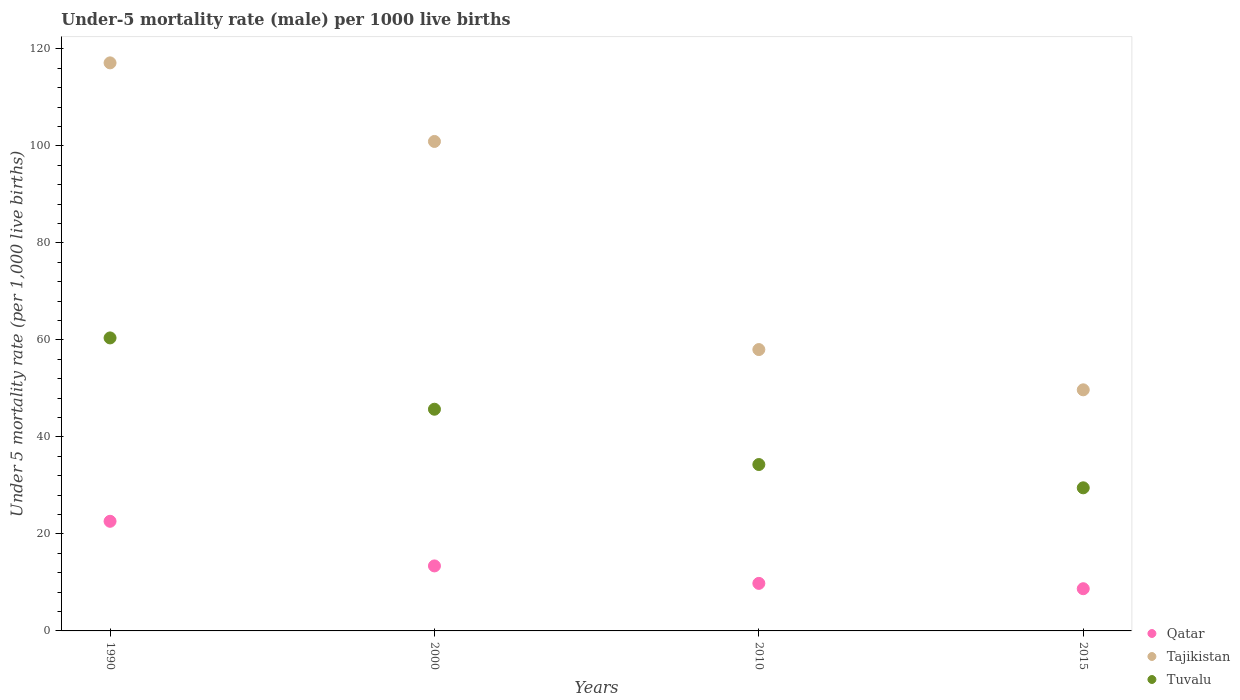What is the under-five mortality rate in Tuvalu in 2015?
Your response must be concise. 29.5. Across all years, what is the maximum under-five mortality rate in Qatar?
Your answer should be very brief. 22.6. In which year was the under-five mortality rate in Tajikistan minimum?
Your answer should be compact. 2015. What is the total under-five mortality rate in Tuvalu in the graph?
Your answer should be very brief. 169.9. What is the difference between the under-five mortality rate in Tajikistan in 1990 and that in 2015?
Your answer should be very brief. 67.4. What is the difference between the under-five mortality rate in Tajikistan in 2000 and the under-five mortality rate in Qatar in 2010?
Provide a short and direct response. 91.1. What is the average under-five mortality rate in Qatar per year?
Provide a succinct answer. 13.62. In the year 2000, what is the difference between the under-five mortality rate in Tajikistan and under-five mortality rate in Tuvalu?
Your response must be concise. 55.2. What is the ratio of the under-five mortality rate in Qatar in 2000 to that in 2015?
Offer a very short reply. 1.54. Is the under-five mortality rate in Tajikistan in 2010 less than that in 2015?
Give a very brief answer. No. Is the difference between the under-five mortality rate in Tajikistan in 1990 and 2000 greater than the difference between the under-five mortality rate in Tuvalu in 1990 and 2000?
Your answer should be very brief. Yes. What is the difference between the highest and the second highest under-five mortality rate in Tuvalu?
Provide a succinct answer. 14.7. What is the difference between the highest and the lowest under-five mortality rate in Tuvalu?
Offer a very short reply. 30.9. Does the under-five mortality rate in Qatar monotonically increase over the years?
Provide a short and direct response. No. Is the under-five mortality rate in Tajikistan strictly greater than the under-five mortality rate in Qatar over the years?
Give a very brief answer. Yes. Is the under-five mortality rate in Tajikistan strictly less than the under-five mortality rate in Qatar over the years?
Provide a short and direct response. No. What is the difference between two consecutive major ticks on the Y-axis?
Keep it short and to the point. 20. Does the graph contain grids?
Your answer should be compact. No. Where does the legend appear in the graph?
Make the answer very short. Bottom right. What is the title of the graph?
Your response must be concise. Under-5 mortality rate (male) per 1000 live births. Does "Jamaica" appear as one of the legend labels in the graph?
Provide a short and direct response. No. What is the label or title of the Y-axis?
Offer a terse response. Under 5 mortality rate (per 1,0 live births). What is the Under 5 mortality rate (per 1,000 live births) of Qatar in 1990?
Your answer should be compact. 22.6. What is the Under 5 mortality rate (per 1,000 live births) of Tajikistan in 1990?
Make the answer very short. 117.1. What is the Under 5 mortality rate (per 1,000 live births) in Tuvalu in 1990?
Your response must be concise. 60.4. What is the Under 5 mortality rate (per 1,000 live births) of Tajikistan in 2000?
Your answer should be very brief. 100.9. What is the Under 5 mortality rate (per 1,000 live births) of Tuvalu in 2000?
Keep it short and to the point. 45.7. What is the Under 5 mortality rate (per 1,000 live births) in Qatar in 2010?
Provide a succinct answer. 9.8. What is the Under 5 mortality rate (per 1,000 live births) in Tajikistan in 2010?
Your answer should be very brief. 58. What is the Under 5 mortality rate (per 1,000 live births) in Tuvalu in 2010?
Provide a short and direct response. 34.3. What is the Under 5 mortality rate (per 1,000 live births) of Tajikistan in 2015?
Provide a short and direct response. 49.7. What is the Under 5 mortality rate (per 1,000 live births) in Tuvalu in 2015?
Your answer should be compact. 29.5. Across all years, what is the maximum Under 5 mortality rate (per 1,000 live births) of Qatar?
Keep it short and to the point. 22.6. Across all years, what is the maximum Under 5 mortality rate (per 1,000 live births) of Tajikistan?
Offer a very short reply. 117.1. Across all years, what is the maximum Under 5 mortality rate (per 1,000 live births) of Tuvalu?
Give a very brief answer. 60.4. Across all years, what is the minimum Under 5 mortality rate (per 1,000 live births) of Qatar?
Provide a succinct answer. 8.7. Across all years, what is the minimum Under 5 mortality rate (per 1,000 live births) of Tajikistan?
Provide a succinct answer. 49.7. Across all years, what is the minimum Under 5 mortality rate (per 1,000 live births) of Tuvalu?
Ensure brevity in your answer.  29.5. What is the total Under 5 mortality rate (per 1,000 live births) of Qatar in the graph?
Offer a very short reply. 54.5. What is the total Under 5 mortality rate (per 1,000 live births) of Tajikistan in the graph?
Make the answer very short. 325.7. What is the total Under 5 mortality rate (per 1,000 live births) of Tuvalu in the graph?
Offer a terse response. 169.9. What is the difference between the Under 5 mortality rate (per 1,000 live births) in Qatar in 1990 and that in 2000?
Make the answer very short. 9.2. What is the difference between the Under 5 mortality rate (per 1,000 live births) in Tajikistan in 1990 and that in 2010?
Your answer should be compact. 59.1. What is the difference between the Under 5 mortality rate (per 1,000 live births) in Tuvalu in 1990 and that in 2010?
Make the answer very short. 26.1. What is the difference between the Under 5 mortality rate (per 1,000 live births) of Tajikistan in 1990 and that in 2015?
Keep it short and to the point. 67.4. What is the difference between the Under 5 mortality rate (per 1,000 live births) of Tuvalu in 1990 and that in 2015?
Give a very brief answer. 30.9. What is the difference between the Under 5 mortality rate (per 1,000 live births) in Tajikistan in 2000 and that in 2010?
Your response must be concise. 42.9. What is the difference between the Under 5 mortality rate (per 1,000 live births) of Tajikistan in 2000 and that in 2015?
Provide a succinct answer. 51.2. What is the difference between the Under 5 mortality rate (per 1,000 live births) in Tuvalu in 2000 and that in 2015?
Offer a very short reply. 16.2. What is the difference between the Under 5 mortality rate (per 1,000 live births) of Tajikistan in 2010 and that in 2015?
Offer a terse response. 8.3. What is the difference between the Under 5 mortality rate (per 1,000 live births) of Tuvalu in 2010 and that in 2015?
Give a very brief answer. 4.8. What is the difference between the Under 5 mortality rate (per 1,000 live births) of Qatar in 1990 and the Under 5 mortality rate (per 1,000 live births) of Tajikistan in 2000?
Your response must be concise. -78.3. What is the difference between the Under 5 mortality rate (per 1,000 live births) in Qatar in 1990 and the Under 5 mortality rate (per 1,000 live births) in Tuvalu in 2000?
Make the answer very short. -23.1. What is the difference between the Under 5 mortality rate (per 1,000 live births) in Tajikistan in 1990 and the Under 5 mortality rate (per 1,000 live births) in Tuvalu in 2000?
Ensure brevity in your answer.  71.4. What is the difference between the Under 5 mortality rate (per 1,000 live births) in Qatar in 1990 and the Under 5 mortality rate (per 1,000 live births) in Tajikistan in 2010?
Provide a short and direct response. -35.4. What is the difference between the Under 5 mortality rate (per 1,000 live births) in Qatar in 1990 and the Under 5 mortality rate (per 1,000 live births) in Tuvalu in 2010?
Your response must be concise. -11.7. What is the difference between the Under 5 mortality rate (per 1,000 live births) of Tajikistan in 1990 and the Under 5 mortality rate (per 1,000 live births) of Tuvalu in 2010?
Your answer should be very brief. 82.8. What is the difference between the Under 5 mortality rate (per 1,000 live births) in Qatar in 1990 and the Under 5 mortality rate (per 1,000 live births) in Tajikistan in 2015?
Offer a terse response. -27.1. What is the difference between the Under 5 mortality rate (per 1,000 live births) in Tajikistan in 1990 and the Under 5 mortality rate (per 1,000 live births) in Tuvalu in 2015?
Offer a terse response. 87.6. What is the difference between the Under 5 mortality rate (per 1,000 live births) in Qatar in 2000 and the Under 5 mortality rate (per 1,000 live births) in Tajikistan in 2010?
Provide a short and direct response. -44.6. What is the difference between the Under 5 mortality rate (per 1,000 live births) of Qatar in 2000 and the Under 5 mortality rate (per 1,000 live births) of Tuvalu in 2010?
Offer a terse response. -20.9. What is the difference between the Under 5 mortality rate (per 1,000 live births) in Tajikistan in 2000 and the Under 5 mortality rate (per 1,000 live births) in Tuvalu in 2010?
Provide a short and direct response. 66.6. What is the difference between the Under 5 mortality rate (per 1,000 live births) in Qatar in 2000 and the Under 5 mortality rate (per 1,000 live births) in Tajikistan in 2015?
Offer a terse response. -36.3. What is the difference between the Under 5 mortality rate (per 1,000 live births) in Qatar in 2000 and the Under 5 mortality rate (per 1,000 live births) in Tuvalu in 2015?
Make the answer very short. -16.1. What is the difference between the Under 5 mortality rate (per 1,000 live births) in Tajikistan in 2000 and the Under 5 mortality rate (per 1,000 live births) in Tuvalu in 2015?
Your response must be concise. 71.4. What is the difference between the Under 5 mortality rate (per 1,000 live births) of Qatar in 2010 and the Under 5 mortality rate (per 1,000 live births) of Tajikistan in 2015?
Your answer should be compact. -39.9. What is the difference between the Under 5 mortality rate (per 1,000 live births) in Qatar in 2010 and the Under 5 mortality rate (per 1,000 live births) in Tuvalu in 2015?
Keep it short and to the point. -19.7. What is the difference between the Under 5 mortality rate (per 1,000 live births) of Tajikistan in 2010 and the Under 5 mortality rate (per 1,000 live births) of Tuvalu in 2015?
Your response must be concise. 28.5. What is the average Under 5 mortality rate (per 1,000 live births) of Qatar per year?
Your response must be concise. 13.62. What is the average Under 5 mortality rate (per 1,000 live births) in Tajikistan per year?
Ensure brevity in your answer.  81.42. What is the average Under 5 mortality rate (per 1,000 live births) of Tuvalu per year?
Provide a succinct answer. 42.48. In the year 1990, what is the difference between the Under 5 mortality rate (per 1,000 live births) in Qatar and Under 5 mortality rate (per 1,000 live births) in Tajikistan?
Provide a succinct answer. -94.5. In the year 1990, what is the difference between the Under 5 mortality rate (per 1,000 live births) in Qatar and Under 5 mortality rate (per 1,000 live births) in Tuvalu?
Your answer should be very brief. -37.8. In the year 1990, what is the difference between the Under 5 mortality rate (per 1,000 live births) in Tajikistan and Under 5 mortality rate (per 1,000 live births) in Tuvalu?
Your answer should be very brief. 56.7. In the year 2000, what is the difference between the Under 5 mortality rate (per 1,000 live births) of Qatar and Under 5 mortality rate (per 1,000 live births) of Tajikistan?
Offer a terse response. -87.5. In the year 2000, what is the difference between the Under 5 mortality rate (per 1,000 live births) of Qatar and Under 5 mortality rate (per 1,000 live births) of Tuvalu?
Provide a short and direct response. -32.3. In the year 2000, what is the difference between the Under 5 mortality rate (per 1,000 live births) in Tajikistan and Under 5 mortality rate (per 1,000 live births) in Tuvalu?
Offer a terse response. 55.2. In the year 2010, what is the difference between the Under 5 mortality rate (per 1,000 live births) in Qatar and Under 5 mortality rate (per 1,000 live births) in Tajikistan?
Your answer should be very brief. -48.2. In the year 2010, what is the difference between the Under 5 mortality rate (per 1,000 live births) in Qatar and Under 5 mortality rate (per 1,000 live births) in Tuvalu?
Offer a very short reply. -24.5. In the year 2010, what is the difference between the Under 5 mortality rate (per 1,000 live births) of Tajikistan and Under 5 mortality rate (per 1,000 live births) of Tuvalu?
Your answer should be very brief. 23.7. In the year 2015, what is the difference between the Under 5 mortality rate (per 1,000 live births) in Qatar and Under 5 mortality rate (per 1,000 live births) in Tajikistan?
Offer a very short reply. -41. In the year 2015, what is the difference between the Under 5 mortality rate (per 1,000 live births) in Qatar and Under 5 mortality rate (per 1,000 live births) in Tuvalu?
Your response must be concise. -20.8. In the year 2015, what is the difference between the Under 5 mortality rate (per 1,000 live births) of Tajikistan and Under 5 mortality rate (per 1,000 live births) of Tuvalu?
Ensure brevity in your answer.  20.2. What is the ratio of the Under 5 mortality rate (per 1,000 live births) of Qatar in 1990 to that in 2000?
Your answer should be compact. 1.69. What is the ratio of the Under 5 mortality rate (per 1,000 live births) of Tajikistan in 1990 to that in 2000?
Provide a succinct answer. 1.16. What is the ratio of the Under 5 mortality rate (per 1,000 live births) of Tuvalu in 1990 to that in 2000?
Your response must be concise. 1.32. What is the ratio of the Under 5 mortality rate (per 1,000 live births) of Qatar in 1990 to that in 2010?
Ensure brevity in your answer.  2.31. What is the ratio of the Under 5 mortality rate (per 1,000 live births) of Tajikistan in 1990 to that in 2010?
Give a very brief answer. 2.02. What is the ratio of the Under 5 mortality rate (per 1,000 live births) of Tuvalu in 1990 to that in 2010?
Your response must be concise. 1.76. What is the ratio of the Under 5 mortality rate (per 1,000 live births) in Qatar in 1990 to that in 2015?
Make the answer very short. 2.6. What is the ratio of the Under 5 mortality rate (per 1,000 live births) of Tajikistan in 1990 to that in 2015?
Offer a terse response. 2.36. What is the ratio of the Under 5 mortality rate (per 1,000 live births) of Tuvalu in 1990 to that in 2015?
Offer a terse response. 2.05. What is the ratio of the Under 5 mortality rate (per 1,000 live births) of Qatar in 2000 to that in 2010?
Give a very brief answer. 1.37. What is the ratio of the Under 5 mortality rate (per 1,000 live births) of Tajikistan in 2000 to that in 2010?
Offer a terse response. 1.74. What is the ratio of the Under 5 mortality rate (per 1,000 live births) in Tuvalu in 2000 to that in 2010?
Your answer should be compact. 1.33. What is the ratio of the Under 5 mortality rate (per 1,000 live births) in Qatar in 2000 to that in 2015?
Provide a succinct answer. 1.54. What is the ratio of the Under 5 mortality rate (per 1,000 live births) of Tajikistan in 2000 to that in 2015?
Offer a very short reply. 2.03. What is the ratio of the Under 5 mortality rate (per 1,000 live births) of Tuvalu in 2000 to that in 2015?
Offer a terse response. 1.55. What is the ratio of the Under 5 mortality rate (per 1,000 live births) of Qatar in 2010 to that in 2015?
Provide a succinct answer. 1.13. What is the ratio of the Under 5 mortality rate (per 1,000 live births) in Tajikistan in 2010 to that in 2015?
Make the answer very short. 1.17. What is the ratio of the Under 5 mortality rate (per 1,000 live births) of Tuvalu in 2010 to that in 2015?
Ensure brevity in your answer.  1.16. What is the difference between the highest and the second highest Under 5 mortality rate (per 1,000 live births) in Qatar?
Your answer should be compact. 9.2. What is the difference between the highest and the second highest Under 5 mortality rate (per 1,000 live births) in Tajikistan?
Give a very brief answer. 16.2. What is the difference between the highest and the second highest Under 5 mortality rate (per 1,000 live births) of Tuvalu?
Provide a short and direct response. 14.7. What is the difference between the highest and the lowest Under 5 mortality rate (per 1,000 live births) in Tajikistan?
Offer a very short reply. 67.4. What is the difference between the highest and the lowest Under 5 mortality rate (per 1,000 live births) in Tuvalu?
Your answer should be very brief. 30.9. 